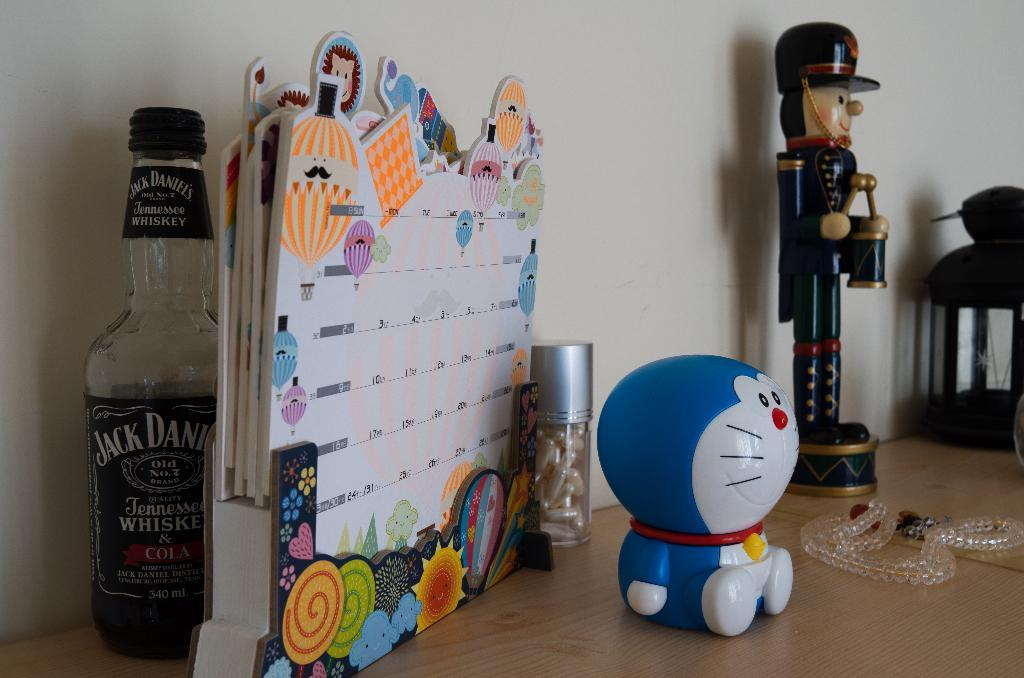What piece of furniture is present in the image? There is a table in the image. What object related to a pet can be seen on the table? There is a cat toy on the table. What item is used for tracking dates and events on the table? There is a calendar on the table. What type of container holds capsules in the image? There is a bottle containing capsules in the image. What type of beverage is associated with the wine bottle in the image? The wine bottle in the image is associated with a type of alcoholic beverage. What type of cart is used to transport the wine bottle in the image? There is no cart present in the image; the wine bottle is behind the calendar on the table. 